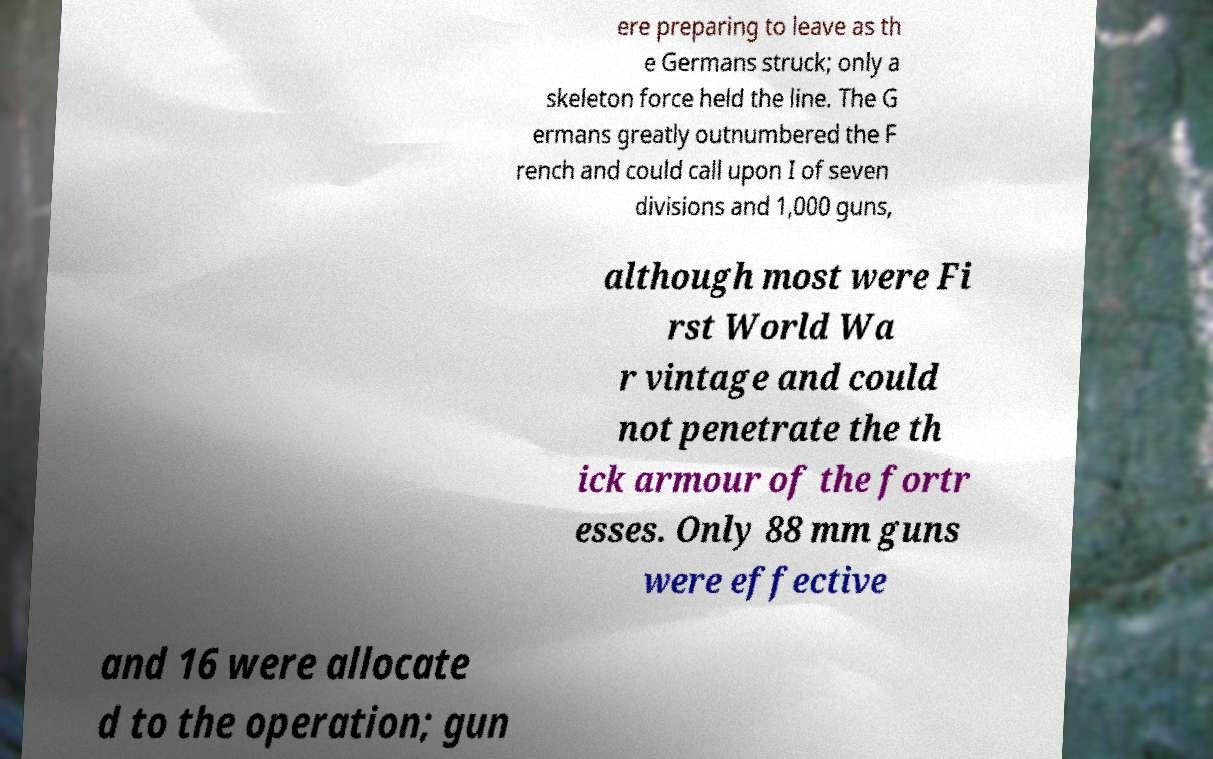Please identify and transcribe the text found in this image. ere preparing to leave as th e Germans struck; only a skeleton force held the line. The G ermans greatly outnumbered the F rench and could call upon I of seven divisions and 1,000 guns, although most were Fi rst World Wa r vintage and could not penetrate the th ick armour of the fortr esses. Only 88 mm guns were effective and 16 were allocate d to the operation; gun 